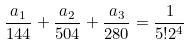<formula> <loc_0><loc_0><loc_500><loc_500>\frac { a _ { 1 } } { 1 4 4 } + \frac { a _ { 2 } } { 5 0 4 } + \frac { a _ { 3 } } { 2 8 0 } = \frac { 1 } { 5 ! 2 ^ { 4 } }</formula> 